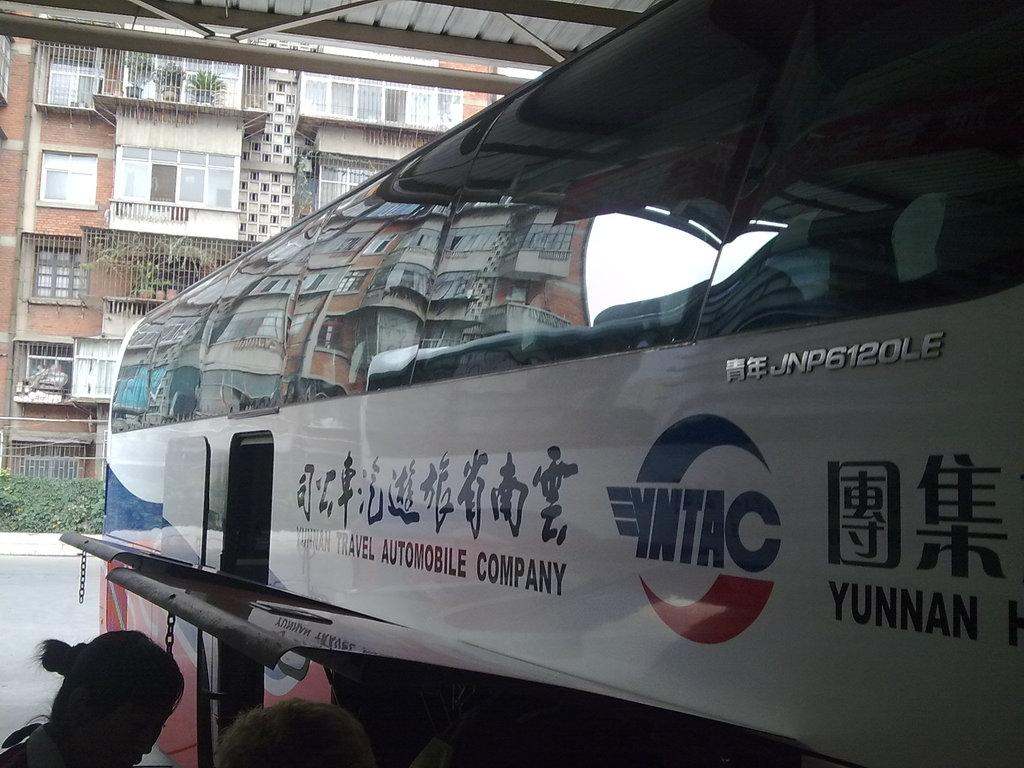What type of vehicle is in the image? There is a mobile company bus in the image. What colors can be seen on the bus? The bus is white, blue, and red in color. What can be seen in the background of the image? There are buildings, plants, and fencing in the background of the image. How many cats are sitting on the roof of the bus in the image? There are no cats present in the image; it only features a mobile company bus and the background elements. 